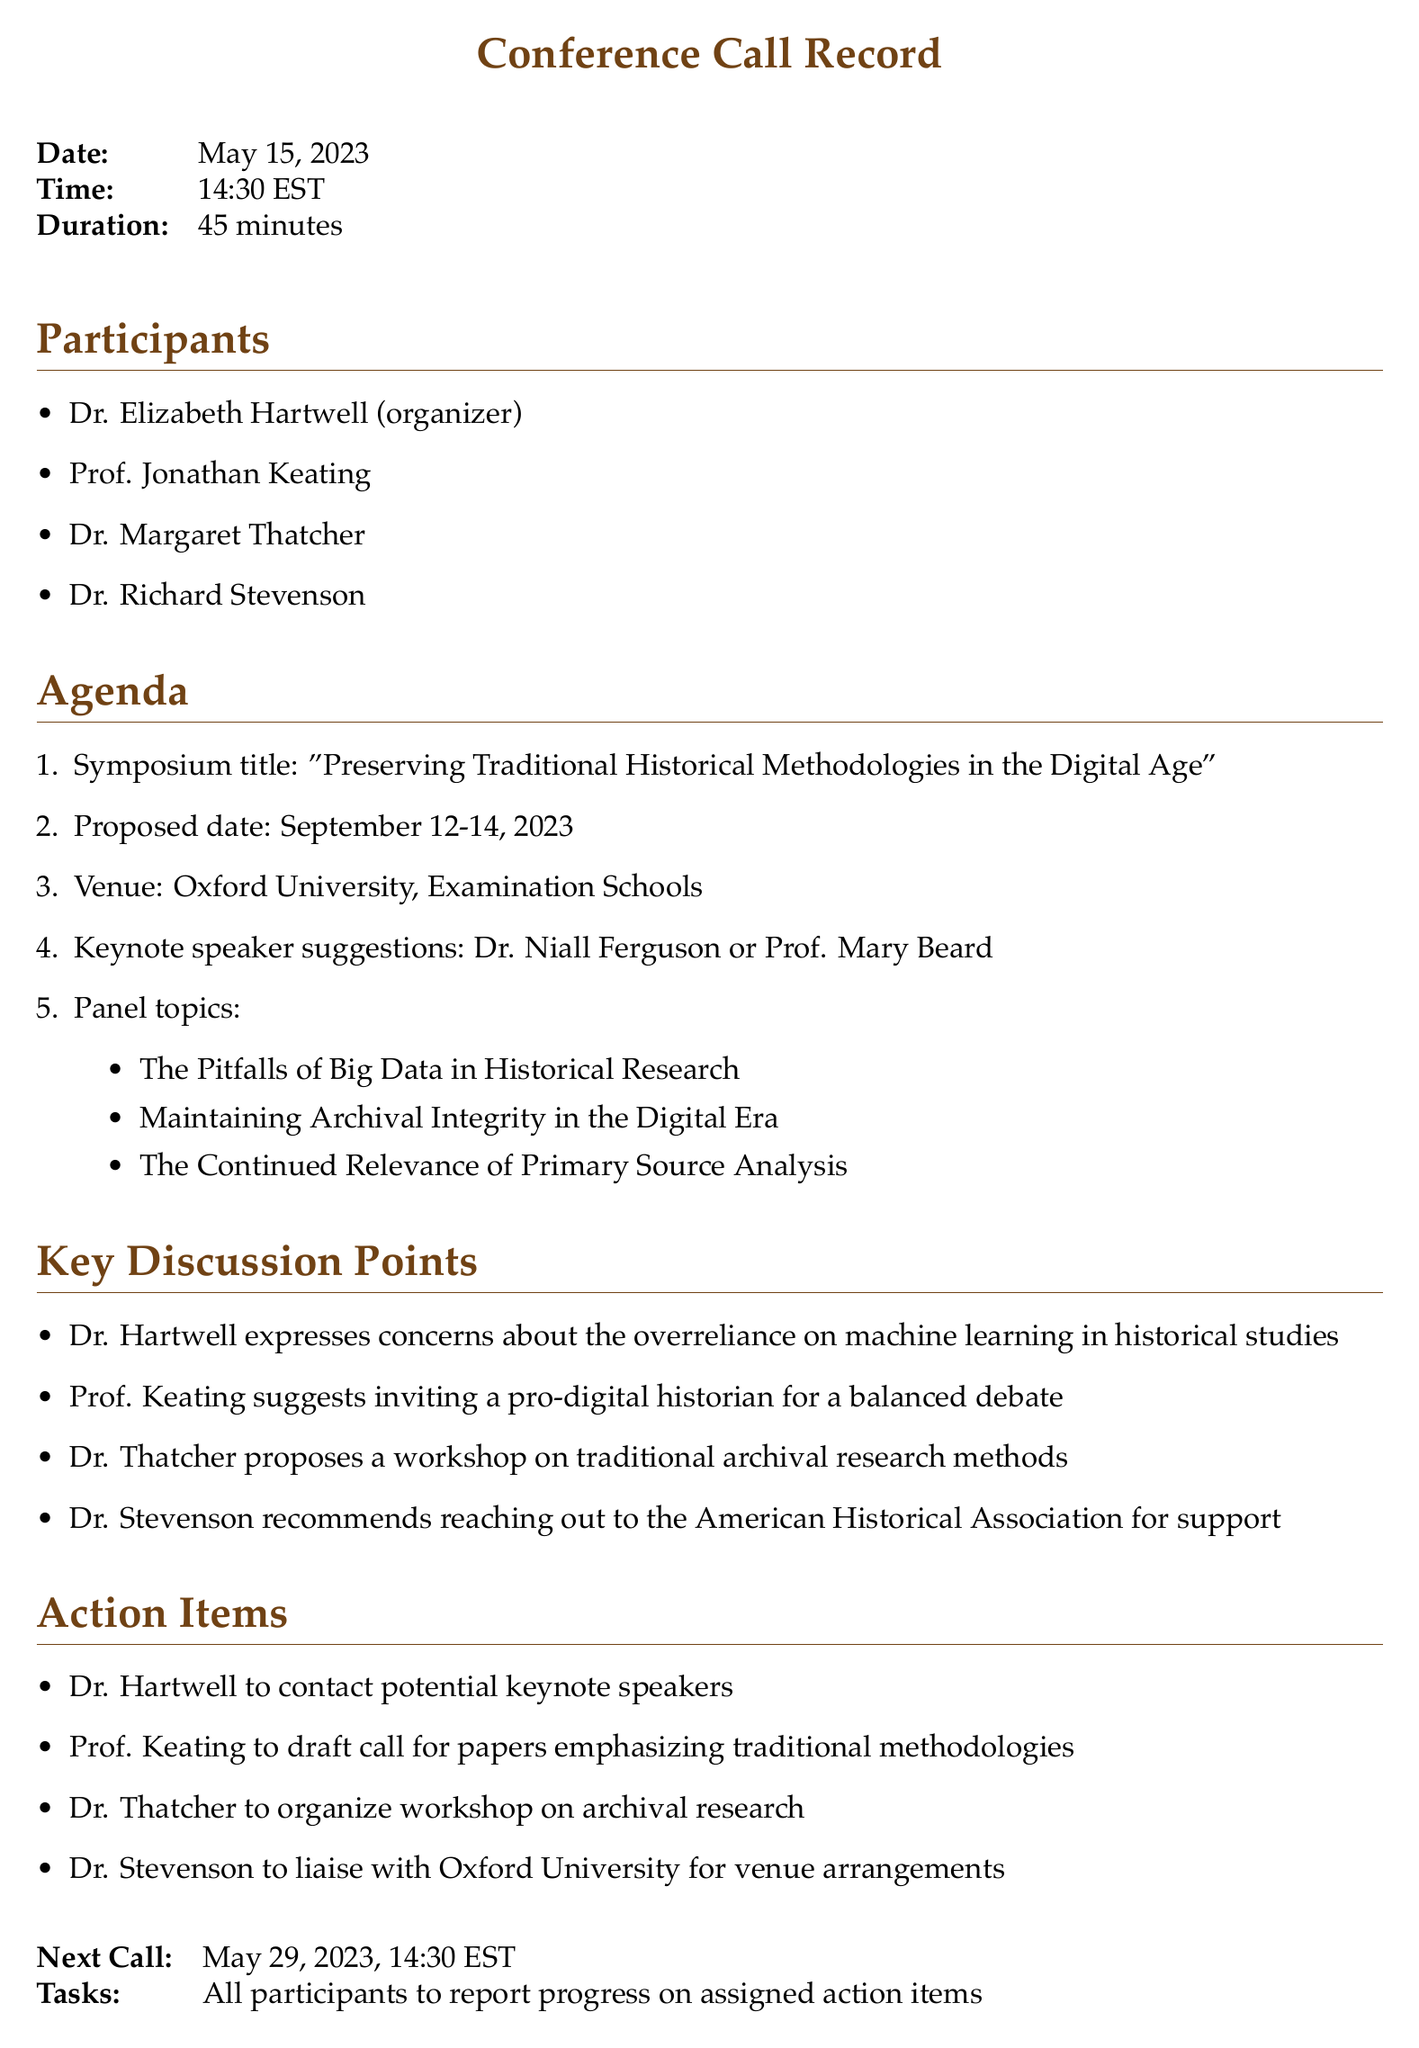What is the date of the conference call? The date is explicitly stated at the beginning of the document.
Answer: May 15, 2023 Who is the organizer of the symposium? The document lists Dr. Elizabeth Hartwell as the organizer under the participants section.
Answer: Dr. Elizabeth Hartwell What is the proposed symposium title? The title is specified in the agenda section of the document.
Answer: "Preserving Traditional Historical Methodologies in the Digital Age" What is the duration of the conference call? The duration is indicated in the details at the top of the document.
Answer: 45 minutes Which university will host the symposium? The venue of the symposium is mentioned within the agenda section.
Answer: Oxford University What is one of the key discussion points regarding machine learning? The discussion points include concerns specifically addressed by Dr. Hartwell about machine learning.
Answer: Overreliance on machine learning Who will draft the call for papers? The action items specify which participant is responsible for each task.
Answer: Prof. Keating When is the next conference call scheduled? The document clearly states the date for the next call at the end.
Answer: May 29, 2023 What is one proposed panel topic? The document outlines specific topics for panels within the agenda section.
Answer: The Pitfalls of Big Data in Historical Research 